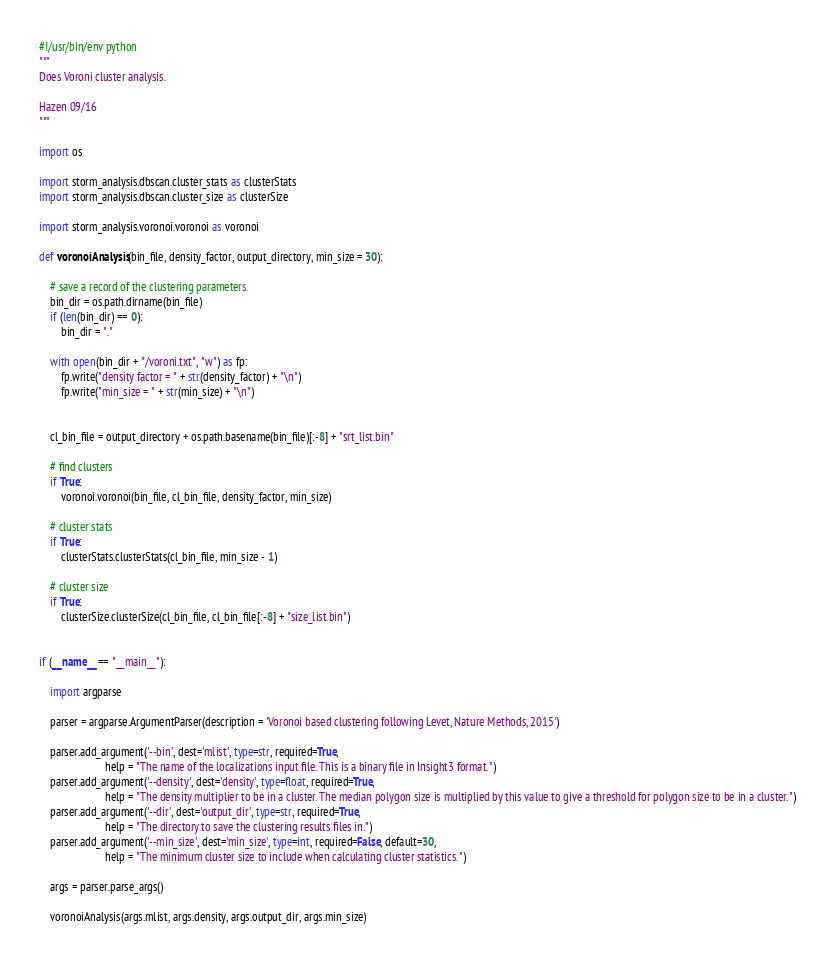Convert code to text. <code><loc_0><loc_0><loc_500><loc_500><_Python_>#!/usr/bin/env python
"""
Does Voroni cluster analysis.

Hazen 09/16
"""

import os

import storm_analysis.dbscan.cluster_stats as clusterStats
import storm_analysis.dbscan.cluster_size as clusterSize

import storm_analysis.voronoi.voronoi as voronoi

def voronoiAnalysis(bin_file, density_factor, output_directory, min_size = 30):

    # save a record of the clustering parameters.    
    bin_dir = os.path.dirname(bin_file)
    if (len(bin_dir) == 0):
        bin_dir = "."
    
    with open(bin_dir + "/voroni.txt", "w") as fp:
        fp.write("density factor = " + str(density_factor) + "\n")
        fp.write("min_size = " + str(min_size) + "\n")


    cl_bin_file = output_directory + os.path.basename(bin_file)[:-8] + "srt_list.bin"

    # find clusters
    if True:
        voronoi.voronoi(bin_file, cl_bin_file, density_factor, min_size)

    # cluster stats
    if True:
        clusterStats.clusterStats(cl_bin_file, min_size - 1)

    # cluster size
    if True:
        clusterSize.clusterSize(cl_bin_file, cl_bin_file[:-8] + "size_list.bin")


if (__name__ == "__main__"):

    import argparse

    parser = argparse.ArgumentParser(description = 'Voronoi based clustering following Levet, Nature Methods, 2015')

    parser.add_argument('--bin', dest='mlist', type=str, required=True,
                        help = "The name of the localizations input file. This is a binary file in Insight3 format.")
    parser.add_argument('--density', dest='density', type=float, required=True,
                        help = "The density multiplier to be in a cluster. The median polygon size is multiplied by this value to give a threshold for polygon size to be in a cluster.")
    parser.add_argument('--dir', dest='output_dir', type=str, required=True,
                        help = "The directory to save the clustering results files in.")
    parser.add_argument('--min_size', dest='min_size', type=int, required=False, default=30,
                        help = "The minimum cluster size to include when calculating cluster statistics.")

    args = parser.parse_args()

    voronoiAnalysis(args.mlist, args.density, args.output_dir, args.min_size)


</code> 